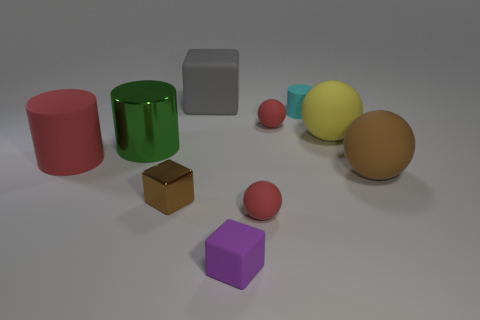Are there more large gray objects that are to the right of the purple block than cyan matte things that are left of the large red matte thing?
Your answer should be compact. No. How many large balls are the same color as the tiny metal block?
Keep it short and to the point. 1. There is a green thing that is the same material as the small brown block; what is its size?
Make the answer very short. Large. How many things are either tiny objects that are behind the purple thing or large metallic cylinders?
Your answer should be very brief. 5. Does the big metal object that is in front of the small cyan matte object have the same color as the tiny cylinder?
Offer a very short reply. No. There is a yellow matte object that is the same shape as the brown rubber object; what is its size?
Ensure brevity in your answer.  Large. The metallic thing behind the tiny cube that is behind the small sphere that is in front of the large brown rubber ball is what color?
Offer a very short reply. Green. Do the big gray block and the small cyan object have the same material?
Provide a succinct answer. Yes. There is a red ball that is right of the tiny red thing in front of the red cylinder; is there a large green shiny object behind it?
Offer a terse response. No. Is the large cube the same color as the shiny cylinder?
Offer a terse response. No. 